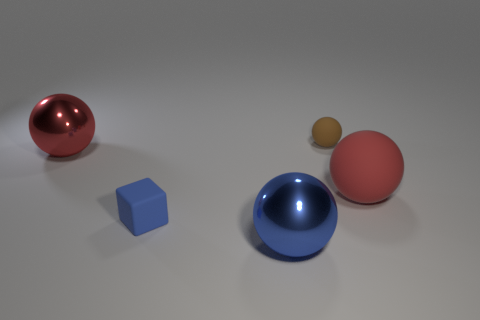What size is the red object that is right of the small block behind the metal ball that is on the right side of the blue cube?
Provide a succinct answer. Large. There is a rubber object to the left of the brown object; is its color the same as the shiny sphere that is behind the large blue thing?
Keep it short and to the point. No. How many red objects are either big rubber objects or small rubber cubes?
Your response must be concise. 1. What number of objects are the same size as the red rubber ball?
Keep it short and to the point. 2. Are the red ball on the left side of the big red matte object and the tiny brown ball made of the same material?
Offer a very short reply. No. There is a small matte object that is behind the large rubber ball; is there a large red shiny thing that is to the right of it?
Give a very brief answer. No. There is a blue thing that is the same shape as the brown rubber thing; what is it made of?
Provide a succinct answer. Metal. Are there more tiny blue things on the right side of the big blue thing than blue shiny spheres behind the blue matte thing?
Ensure brevity in your answer.  No. What is the shape of the large thing that is the same material as the small blue object?
Provide a succinct answer. Sphere. Are there more large objects that are behind the small blue matte object than red shiny things?
Offer a very short reply. Yes. 